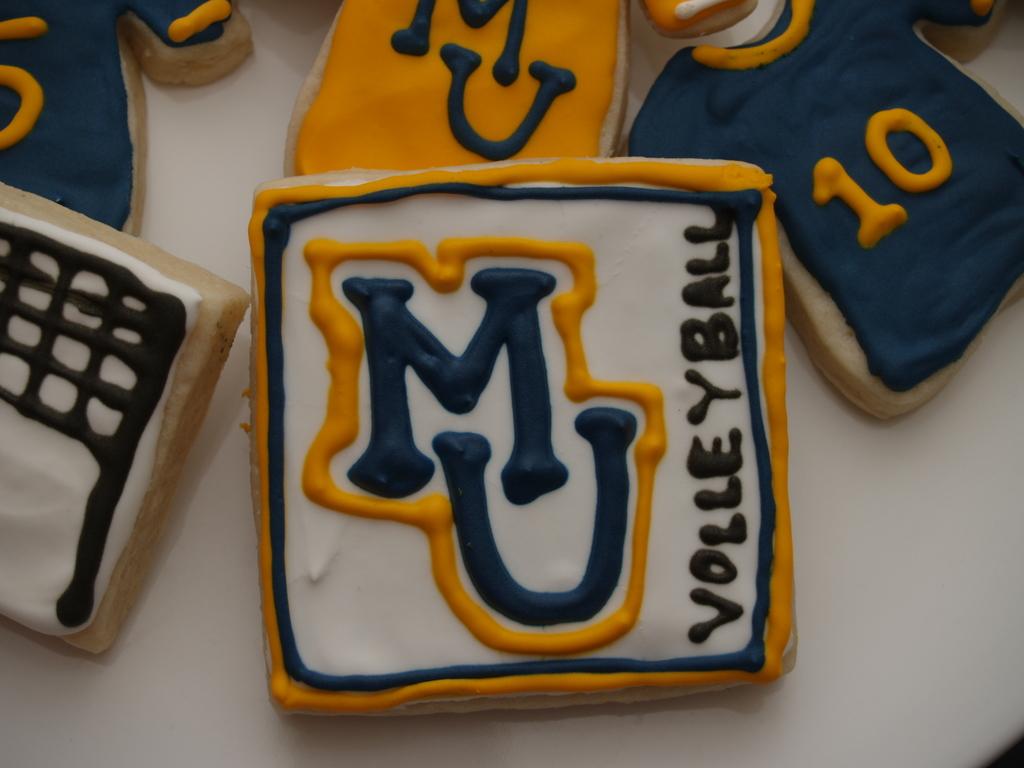What game does the cookie show?
Your response must be concise. Volleyball. What letters does the cookie have on it?
Provide a succinct answer. Mu. 